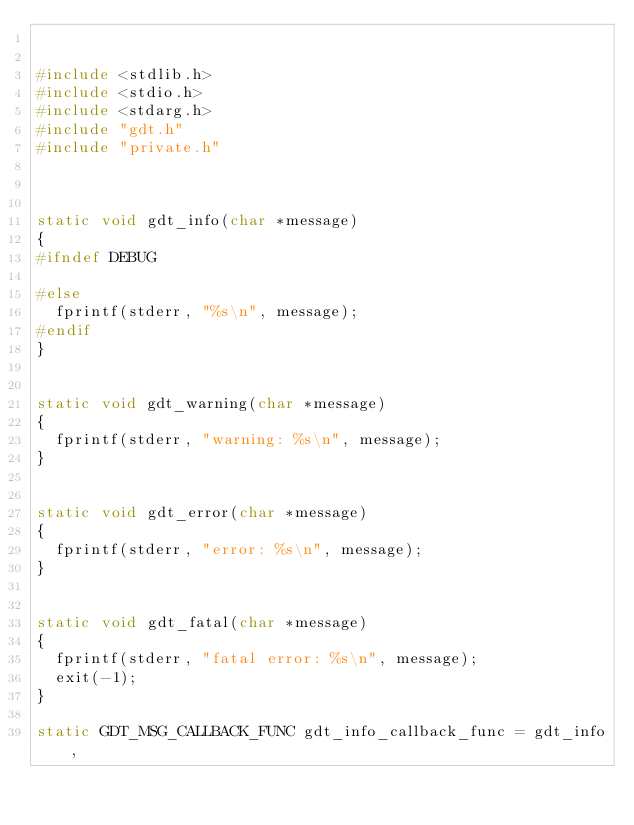<code> <loc_0><loc_0><loc_500><loc_500><_C_>

#include <stdlib.h>
#include <stdio.h>
#include <stdarg.h>
#include "gdt.h"
#include "private.h"



static void gdt_info(char *message)
{
#ifndef DEBUG
  
#else 
  fprintf(stderr, "%s\n", message);
#endif 
}


static void gdt_warning(char *message)
{
  fprintf(stderr, "warning: %s\n", message);
}


static void gdt_error(char *message)
{
  fprintf(stderr, "error: %s\n", message);
}


static void gdt_fatal(char *message)
{
  fprintf(stderr, "fatal error: %s\n", message);
  exit(-1);
}

static GDT_MSG_CALLBACK_FUNC gdt_info_callback_func = gdt_info,</code> 